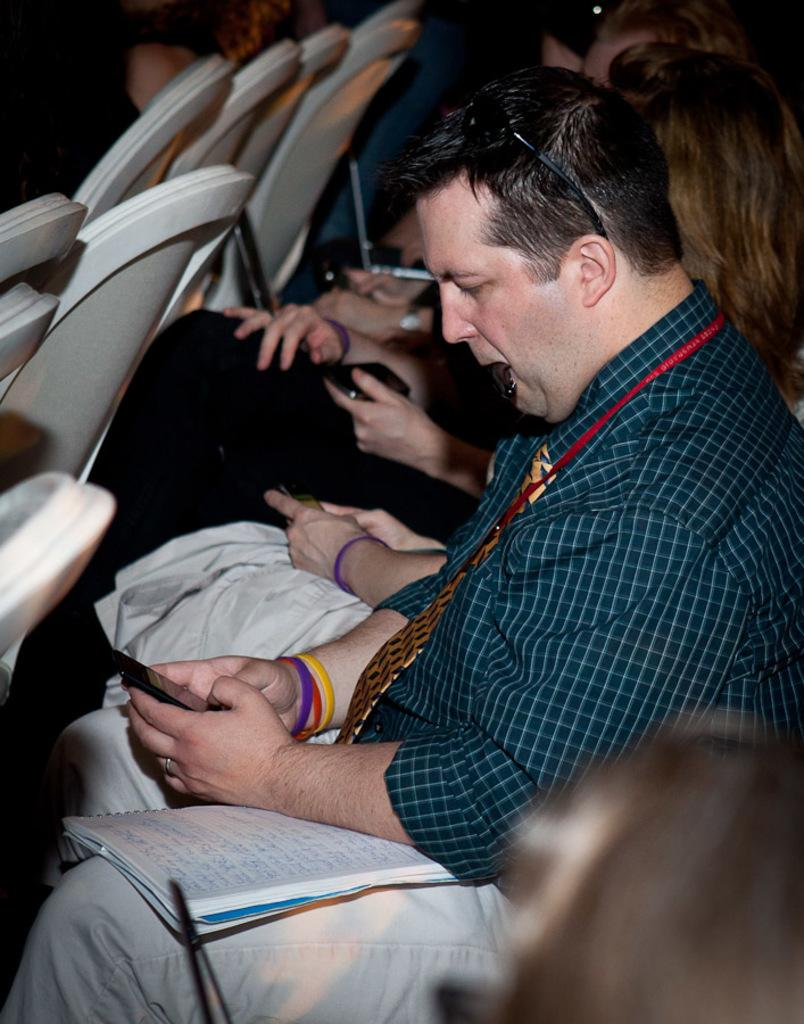What type of furniture is present in the image? There are chairs in the image. Who or what is present in the image? There are people in the image. What type of communication device is visible in the image? There are phones in the image. What type of reading material is present in the image? There is a book in the image. How many girls are holding hands and increasing the number of people in the image? There is no mention of girls or hand-holding in the image, and the number of people cannot be increased as they are already present in the image. 